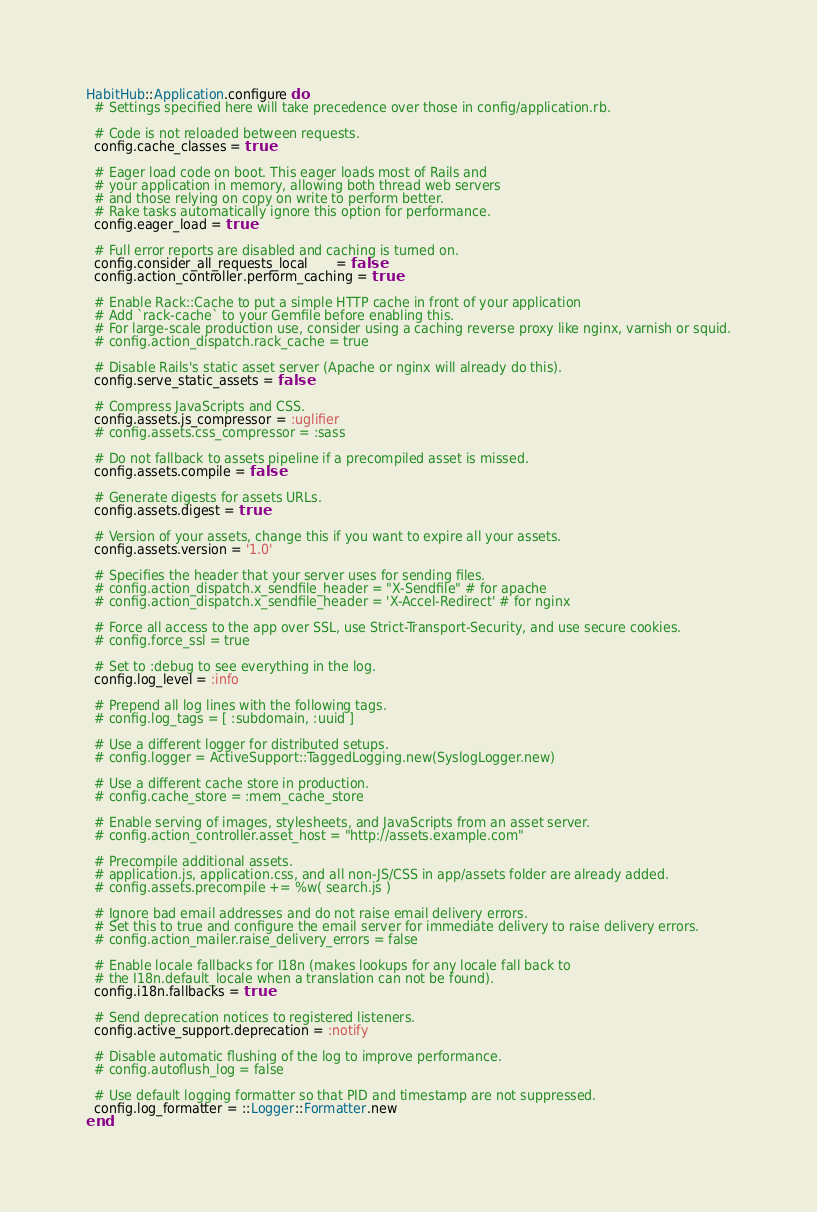Convert code to text. <code><loc_0><loc_0><loc_500><loc_500><_Ruby_>HabitHub::Application.configure do
  # Settings specified here will take precedence over those in config/application.rb.

  # Code is not reloaded between requests.
  config.cache_classes = true

  # Eager load code on boot. This eager loads most of Rails and
  # your application in memory, allowing both thread web servers
  # and those relying on copy on write to perform better.
  # Rake tasks automatically ignore this option for performance.
  config.eager_load = true

  # Full error reports are disabled and caching is turned on.
  config.consider_all_requests_local       = false
  config.action_controller.perform_caching = true

  # Enable Rack::Cache to put a simple HTTP cache in front of your application
  # Add `rack-cache` to your Gemfile before enabling this.
  # For large-scale production use, consider using a caching reverse proxy like nginx, varnish or squid.
  # config.action_dispatch.rack_cache = true

  # Disable Rails's static asset server (Apache or nginx will already do this).
  config.serve_static_assets = false

  # Compress JavaScripts and CSS.
  config.assets.js_compressor = :uglifier
  # config.assets.css_compressor = :sass

  # Do not fallback to assets pipeline if a precompiled asset is missed.
  config.assets.compile = false

  # Generate digests for assets URLs.
  config.assets.digest = true

  # Version of your assets, change this if you want to expire all your assets.
  config.assets.version = '1.0'

  # Specifies the header that your server uses for sending files.
  # config.action_dispatch.x_sendfile_header = "X-Sendfile" # for apache
  # config.action_dispatch.x_sendfile_header = 'X-Accel-Redirect' # for nginx

  # Force all access to the app over SSL, use Strict-Transport-Security, and use secure cookies.
  # config.force_ssl = true

  # Set to :debug to see everything in the log.
  config.log_level = :info

  # Prepend all log lines with the following tags.
  # config.log_tags = [ :subdomain, :uuid ]

  # Use a different logger for distributed setups.
  # config.logger = ActiveSupport::TaggedLogging.new(SyslogLogger.new)

  # Use a different cache store in production.
  # config.cache_store = :mem_cache_store

  # Enable serving of images, stylesheets, and JavaScripts from an asset server.
  # config.action_controller.asset_host = "http://assets.example.com"

  # Precompile additional assets.
  # application.js, application.css, and all non-JS/CSS in app/assets folder are already added.
  # config.assets.precompile += %w( search.js )

  # Ignore bad email addresses and do not raise email delivery errors.
  # Set this to true and configure the email server for immediate delivery to raise delivery errors.
  # config.action_mailer.raise_delivery_errors = false

  # Enable locale fallbacks for I18n (makes lookups for any locale fall back to
  # the I18n.default_locale when a translation can not be found).
  config.i18n.fallbacks = true

  # Send deprecation notices to registered listeners.
  config.active_support.deprecation = :notify

  # Disable automatic flushing of the log to improve performance.
  # config.autoflush_log = false

  # Use default logging formatter so that PID and timestamp are not suppressed.
  config.log_formatter = ::Logger::Formatter.new
end
</code> 